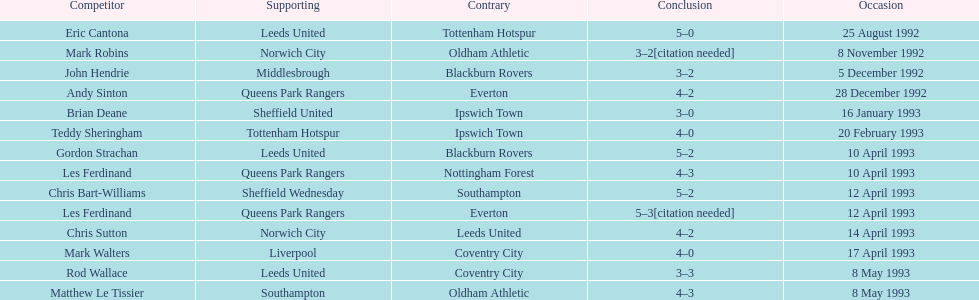Which player had the same result as mark robins? John Hendrie. 